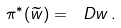Convert formula to latex. <formula><loc_0><loc_0><loc_500><loc_500>\pi ^ { * } ( \widetilde { w } ) = \ D w \, .</formula> 